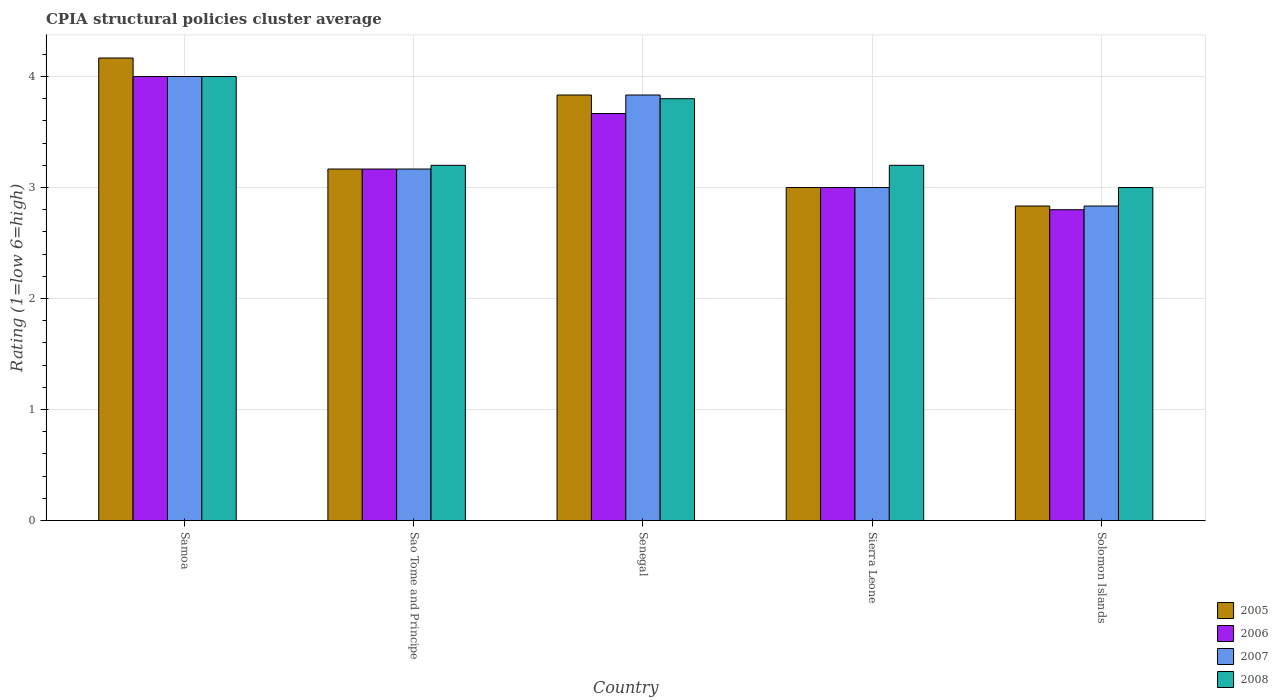Are the number of bars per tick equal to the number of legend labels?
Your answer should be compact. Yes. How many bars are there on the 1st tick from the left?
Your response must be concise. 4. What is the label of the 1st group of bars from the left?
Your response must be concise. Samoa. In how many cases, is the number of bars for a given country not equal to the number of legend labels?
Make the answer very short. 0. What is the CPIA rating in 2005 in Samoa?
Your response must be concise. 4.17. In which country was the CPIA rating in 2008 maximum?
Provide a succinct answer. Samoa. In which country was the CPIA rating in 2006 minimum?
Provide a succinct answer. Solomon Islands. What is the difference between the CPIA rating in 2006 in Senegal and that in Sierra Leone?
Ensure brevity in your answer.  0.67. What is the difference between the CPIA rating in 2006 in Sierra Leone and the CPIA rating in 2008 in Sao Tome and Principe?
Provide a short and direct response. -0.2. What is the average CPIA rating in 2005 per country?
Ensure brevity in your answer.  3.4. What is the difference between the CPIA rating of/in 2006 and CPIA rating of/in 2005 in Solomon Islands?
Your response must be concise. -0.03. In how many countries, is the CPIA rating in 2005 greater than 2.8?
Offer a very short reply. 5. What is the ratio of the CPIA rating in 2007 in Samoa to that in Sierra Leone?
Offer a very short reply. 1.33. Is the CPIA rating in 2005 in Senegal less than that in Sierra Leone?
Your response must be concise. No. Is the difference between the CPIA rating in 2006 in Samoa and Sierra Leone greater than the difference between the CPIA rating in 2005 in Samoa and Sierra Leone?
Provide a short and direct response. No. What is the difference between the highest and the second highest CPIA rating in 2007?
Ensure brevity in your answer.  -0.67. What is the difference between the highest and the lowest CPIA rating in 2007?
Your response must be concise. 1.17. In how many countries, is the CPIA rating in 2006 greater than the average CPIA rating in 2006 taken over all countries?
Offer a very short reply. 2. Is the sum of the CPIA rating in 2007 in Senegal and Sierra Leone greater than the maximum CPIA rating in 2008 across all countries?
Make the answer very short. Yes. Is it the case that in every country, the sum of the CPIA rating in 2007 and CPIA rating in 2006 is greater than the sum of CPIA rating in 2008 and CPIA rating in 2005?
Ensure brevity in your answer.  No. Is it the case that in every country, the sum of the CPIA rating in 2007 and CPIA rating in 2008 is greater than the CPIA rating in 2005?
Make the answer very short. Yes. Are the values on the major ticks of Y-axis written in scientific E-notation?
Ensure brevity in your answer.  No. Does the graph contain any zero values?
Your response must be concise. No. Does the graph contain grids?
Make the answer very short. Yes. Where does the legend appear in the graph?
Ensure brevity in your answer.  Bottom right. How many legend labels are there?
Provide a succinct answer. 4. How are the legend labels stacked?
Make the answer very short. Vertical. What is the title of the graph?
Provide a short and direct response. CPIA structural policies cluster average. Does "1997" appear as one of the legend labels in the graph?
Your answer should be compact. No. What is the label or title of the X-axis?
Provide a succinct answer. Country. What is the Rating (1=low 6=high) of 2005 in Samoa?
Provide a succinct answer. 4.17. What is the Rating (1=low 6=high) in 2006 in Samoa?
Keep it short and to the point. 4. What is the Rating (1=low 6=high) of 2008 in Samoa?
Give a very brief answer. 4. What is the Rating (1=low 6=high) of 2005 in Sao Tome and Principe?
Offer a terse response. 3.17. What is the Rating (1=low 6=high) of 2006 in Sao Tome and Principe?
Keep it short and to the point. 3.17. What is the Rating (1=low 6=high) of 2007 in Sao Tome and Principe?
Ensure brevity in your answer.  3.17. What is the Rating (1=low 6=high) of 2005 in Senegal?
Provide a short and direct response. 3.83. What is the Rating (1=low 6=high) of 2006 in Senegal?
Give a very brief answer. 3.67. What is the Rating (1=low 6=high) of 2007 in Senegal?
Offer a terse response. 3.83. What is the Rating (1=low 6=high) of 2008 in Senegal?
Make the answer very short. 3.8. What is the Rating (1=low 6=high) of 2007 in Sierra Leone?
Ensure brevity in your answer.  3. What is the Rating (1=low 6=high) of 2008 in Sierra Leone?
Make the answer very short. 3.2. What is the Rating (1=low 6=high) in 2005 in Solomon Islands?
Your answer should be compact. 2.83. What is the Rating (1=low 6=high) of 2007 in Solomon Islands?
Your response must be concise. 2.83. Across all countries, what is the maximum Rating (1=low 6=high) of 2005?
Your response must be concise. 4.17. Across all countries, what is the maximum Rating (1=low 6=high) of 2007?
Ensure brevity in your answer.  4. Across all countries, what is the minimum Rating (1=low 6=high) in 2005?
Provide a short and direct response. 2.83. Across all countries, what is the minimum Rating (1=low 6=high) in 2006?
Make the answer very short. 2.8. Across all countries, what is the minimum Rating (1=low 6=high) in 2007?
Your answer should be very brief. 2.83. What is the total Rating (1=low 6=high) in 2006 in the graph?
Offer a very short reply. 16.63. What is the total Rating (1=low 6=high) in 2007 in the graph?
Offer a terse response. 16.83. What is the total Rating (1=low 6=high) of 2008 in the graph?
Provide a succinct answer. 17.2. What is the difference between the Rating (1=low 6=high) in 2005 in Samoa and that in Sao Tome and Principe?
Offer a terse response. 1. What is the difference between the Rating (1=low 6=high) in 2006 in Samoa and that in Senegal?
Provide a succinct answer. 0.33. What is the difference between the Rating (1=low 6=high) of 2008 in Samoa and that in Senegal?
Provide a short and direct response. 0.2. What is the difference between the Rating (1=low 6=high) of 2008 in Samoa and that in Sierra Leone?
Your answer should be very brief. 0.8. What is the difference between the Rating (1=low 6=high) in 2005 in Samoa and that in Solomon Islands?
Provide a succinct answer. 1.33. What is the difference between the Rating (1=low 6=high) in 2005 in Sao Tome and Principe and that in Senegal?
Make the answer very short. -0.67. What is the difference between the Rating (1=low 6=high) of 2006 in Sao Tome and Principe and that in Senegal?
Offer a terse response. -0.5. What is the difference between the Rating (1=low 6=high) of 2008 in Sao Tome and Principe and that in Senegal?
Your answer should be very brief. -0.6. What is the difference between the Rating (1=low 6=high) of 2006 in Sao Tome and Principe and that in Sierra Leone?
Offer a terse response. 0.17. What is the difference between the Rating (1=low 6=high) in 2008 in Sao Tome and Principe and that in Sierra Leone?
Make the answer very short. 0. What is the difference between the Rating (1=low 6=high) in 2006 in Sao Tome and Principe and that in Solomon Islands?
Your answer should be very brief. 0.37. What is the difference between the Rating (1=low 6=high) in 2007 in Sao Tome and Principe and that in Solomon Islands?
Give a very brief answer. 0.33. What is the difference between the Rating (1=low 6=high) of 2008 in Sao Tome and Principe and that in Solomon Islands?
Your response must be concise. 0.2. What is the difference between the Rating (1=low 6=high) of 2006 in Senegal and that in Sierra Leone?
Provide a succinct answer. 0.67. What is the difference between the Rating (1=low 6=high) in 2005 in Senegal and that in Solomon Islands?
Keep it short and to the point. 1. What is the difference between the Rating (1=low 6=high) in 2006 in Senegal and that in Solomon Islands?
Your answer should be very brief. 0.87. What is the difference between the Rating (1=low 6=high) of 2007 in Senegal and that in Solomon Islands?
Your response must be concise. 1. What is the difference between the Rating (1=low 6=high) in 2006 in Sierra Leone and that in Solomon Islands?
Provide a short and direct response. 0.2. What is the difference between the Rating (1=low 6=high) of 2005 in Samoa and the Rating (1=low 6=high) of 2007 in Sao Tome and Principe?
Give a very brief answer. 1. What is the difference between the Rating (1=low 6=high) of 2005 in Samoa and the Rating (1=low 6=high) of 2008 in Sao Tome and Principe?
Your response must be concise. 0.97. What is the difference between the Rating (1=low 6=high) in 2006 in Samoa and the Rating (1=low 6=high) in 2007 in Sao Tome and Principe?
Offer a very short reply. 0.83. What is the difference between the Rating (1=low 6=high) in 2006 in Samoa and the Rating (1=low 6=high) in 2008 in Sao Tome and Principe?
Provide a succinct answer. 0.8. What is the difference between the Rating (1=low 6=high) in 2005 in Samoa and the Rating (1=low 6=high) in 2007 in Senegal?
Keep it short and to the point. 0.33. What is the difference between the Rating (1=low 6=high) of 2005 in Samoa and the Rating (1=low 6=high) of 2008 in Senegal?
Your response must be concise. 0.37. What is the difference between the Rating (1=low 6=high) of 2006 in Samoa and the Rating (1=low 6=high) of 2007 in Senegal?
Offer a terse response. 0.17. What is the difference between the Rating (1=low 6=high) of 2006 in Samoa and the Rating (1=low 6=high) of 2008 in Senegal?
Ensure brevity in your answer.  0.2. What is the difference between the Rating (1=low 6=high) of 2005 in Samoa and the Rating (1=low 6=high) of 2007 in Sierra Leone?
Offer a terse response. 1.17. What is the difference between the Rating (1=low 6=high) in 2005 in Samoa and the Rating (1=low 6=high) in 2008 in Sierra Leone?
Your response must be concise. 0.97. What is the difference between the Rating (1=low 6=high) of 2006 in Samoa and the Rating (1=low 6=high) of 2007 in Sierra Leone?
Ensure brevity in your answer.  1. What is the difference between the Rating (1=low 6=high) in 2007 in Samoa and the Rating (1=low 6=high) in 2008 in Sierra Leone?
Give a very brief answer. 0.8. What is the difference between the Rating (1=low 6=high) of 2005 in Samoa and the Rating (1=low 6=high) of 2006 in Solomon Islands?
Your response must be concise. 1.37. What is the difference between the Rating (1=low 6=high) of 2006 in Samoa and the Rating (1=low 6=high) of 2008 in Solomon Islands?
Provide a short and direct response. 1. What is the difference between the Rating (1=low 6=high) of 2007 in Samoa and the Rating (1=low 6=high) of 2008 in Solomon Islands?
Keep it short and to the point. 1. What is the difference between the Rating (1=low 6=high) in 2005 in Sao Tome and Principe and the Rating (1=low 6=high) in 2006 in Senegal?
Your answer should be very brief. -0.5. What is the difference between the Rating (1=low 6=high) of 2005 in Sao Tome and Principe and the Rating (1=low 6=high) of 2007 in Senegal?
Provide a short and direct response. -0.67. What is the difference between the Rating (1=low 6=high) of 2005 in Sao Tome and Principe and the Rating (1=low 6=high) of 2008 in Senegal?
Offer a terse response. -0.63. What is the difference between the Rating (1=low 6=high) of 2006 in Sao Tome and Principe and the Rating (1=low 6=high) of 2007 in Senegal?
Your answer should be very brief. -0.67. What is the difference between the Rating (1=low 6=high) of 2006 in Sao Tome and Principe and the Rating (1=low 6=high) of 2008 in Senegal?
Make the answer very short. -0.63. What is the difference between the Rating (1=low 6=high) in 2007 in Sao Tome and Principe and the Rating (1=low 6=high) in 2008 in Senegal?
Make the answer very short. -0.63. What is the difference between the Rating (1=low 6=high) in 2005 in Sao Tome and Principe and the Rating (1=low 6=high) in 2008 in Sierra Leone?
Keep it short and to the point. -0.03. What is the difference between the Rating (1=low 6=high) of 2006 in Sao Tome and Principe and the Rating (1=low 6=high) of 2008 in Sierra Leone?
Make the answer very short. -0.03. What is the difference between the Rating (1=low 6=high) in 2007 in Sao Tome and Principe and the Rating (1=low 6=high) in 2008 in Sierra Leone?
Provide a short and direct response. -0.03. What is the difference between the Rating (1=low 6=high) in 2005 in Sao Tome and Principe and the Rating (1=low 6=high) in 2006 in Solomon Islands?
Your answer should be very brief. 0.37. What is the difference between the Rating (1=low 6=high) of 2006 in Sao Tome and Principe and the Rating (1=low 6=high) of 2008 in Solomon Islands?
Provide a short and direct response. 0.17. What is the difference between the Rating (1=low 6=high) of 2005 in Senegal and the Rating (1=low 6=high) of 2007 in Sierra Leone?
Make the answer very short. 0.83. What is the difference between the Rating (1=low 6=high) of 2005 in Senegal and the Rating (1=low 6=high) of 2008 in Sierra Leone?
Make the answer very short. 0.63. What is the difference between the Rating (1=low 6=high) of 2006 in Senegal and the Rating (1=low 6=high) of 2007 in Sierra Leone?
Offer a very short reply. 0.67. What is the difference between the Rating (1=low 6=high) in 2006 in Senegal and the Rating (1=low 6=high) in 2008 in Sierra Leone?
Offer a very short reply. 0.47. What is the difference between the Rating (1=low 6=high) of 2007 in Senegal and the Rating (1=low 6=high) of 2008 in Sierra Leone?
Your answer should be compact. 0.63. What is the difference between the Rating (1=low 6=high) of 2005 in Senegal and the Rating (1=low 6=high) of 2007 in Solomon Islands?
Provide a short and direct response. 1. What is the difference between the Rating (1=low 6=high) in 2006 in Senegal and the Rating (1=low 6=high) in 2007 in Solomon Islands?
Keep it short and to the point. 0.83. What is the difference between the Rating (1=low 6=high) of 2007 in Senegal and the Rating (1=low 6=high) of 2008 in Solomon Islands?
Your response must be concise. 0.83. What is the difference between the Rating (1=low 6=high) of 2006 in Sierra Leone and the Rating (1=low 6=high) of 2007 in Solomon Islands?
Ensure brevity in your answer.  0.17. What is the difference between the Rating (1=low 6=high) of 2006 in Sierra Leone and the Rating (1=low 6=high) of 2008 in Solomon Islands?
Give a very brief answer. 0. What is the difference between the Rating (1=low 6=high) of 2007 in Sierra Leone and the Rating (1=low 6=high) of 2008 in Solomon Islands?
Your response must be concise. 0. What is the average Rating (1=low 6=high) in 2006 per country?
Keep it short and to the point. 3.33. What is the average Rating (1=low 6=high) of 2007 per country?
Ensure brevity in your answer.  3.37. What is the average Rating (1=low 6=high) in 2008 per country?
Provide a short and direct response. 3.44. What is the difference between the Rating (1=low 6=high) of 2005 and Rating (1=low 6=high) of 2008 in Samoa?
Offer a terse response. 0.17. What is the difference between the Rating (1=low 6=high) of 2006 and Rating (1=low 6=high) of 2008 in Samoa?
Your answer should be very brief. 0. What is the difference between the Rating (1=low 6=high) of 2007 and Rating (1=low 6=high) of 2008 in Samoa?
Ensure brevity in your answer.  0. What is the difference between the Rating (1=low 6=high) in 2005 and Rating (1=low 6=high) in 2006 in Sao Tome and Principe?
Your answer should be very brief. 0. What is the difference between the Rating (1=low 6=high) of 2005 and Rating (1=low 6=high) of 2008 in Sao Tome and Principe?
Your answer should be very brief. -0.03. What is the difference between the Rating (1=low 6=high) in 2006 and Rating (1=low 6=high) in 2008 in Sao Tome and Principe?
Your answer should be very brief. -0.03. What is the difference between the Rating (1=low 6=high) of 2007 and Rating (1=low 6=high) of 2008 in Sao Tome and Principe?
Make the answer very short. -0.03. What is the difference between the Rating (1=low 6=high) in 2005 and Rating (1=low 6=high) in 2006 in Senegal?
Provide a short and direct response. 0.17. What is the difference between the Rating (1=low 6=high) of 2005 and Rating (1=low 6=high) of 2007 in Senegal?
Offer a terse response. 0. What is the difference between the Rating (1=low 6=high) in 2006 and Rating (1=low 6=high) in 2008 in Senegal?
Your answer should be compact. -0.13. What is the difference between the Rating (1=low 6=high) in 2007 and Rating (1=low 6=high) in 2008 in Senegal?
Your response must be concise. 0.03. What is the difference between the Rating (1=low 6=high) in 2005 and Rating (1=low 6=high) in 2006 in Sierra Leone?
Your response must be concise. 0. What is the difference between the Rating (1=low 6=high) in 2005 and Rating (1=low 6=high) in 2007 in Sierra Leone?
Your response must be concise. 0. What is the difference between the Rating (1=low 6=high) in 2006 and Rating (1=low 6=high) in 2008 in Sierra Leone?
Provide a short and direct response. -0.2. What is the difference between the Rating (1=low 6=high) in 2006 and Rating (1=low 6=high) in 2007 in Solomon Islands?
Keep it short and to the point. -0.03. What is the difference between the Rating (1=low 6=high) in 2007 and Rating (1=low 6=high) in 2008 in Solomon Islands?
Keep it short and to the point. -0.17. What is the ratio of the Rating (1=low 6=high) of 2005 in Samoa to that in Sao Tome and Principe?
Make the answer very short. 1.32. What is the ratio of the Rating (1=low 6=high) in 2006 in Samoa to that in Sao Tome and Principe?
Your answer should be very brief. 1.26. What is the ratio of the Rating (1=low 6=high) in 2007 in Samoa to that in Sao Tome and Principe?
Your answer should be compact. 1.26. What is the ratio of the Rating (1=low 6=high) in 2008 in Samoa to that in Sao Tome and Principe?
Offer a terse response. 1.25. What is the ratio of the Rating (1=low 6=high) in 2005 in Samoa to that in Senegal?
Your response must be concise. 1.09. What is the ratio of the Rating (1=low 6=high) of 2007 in Samoa to that in Senegal?
Give a very brief answer. 1.04. What is the ratio of the Rating (1=low 6=high) in 2008 in Samoa to that in Senegal?
Your answer should be compact. 1.05. What is the ratio of the Rating (1=low 6=high) of 2005 in Samoa to that in Sierra Leone?
Your response must be concise. 1.39. What is the ratio of the Rating (1=low 6=high) of 2007 in Samoa to that in Sierra Leone?
Your answer should be compact. 1.33. What is the ratio of the Rating (1=low 6=high) in 2005 in Samoa to that in Solomon Islands?
Offer a very short reply. 1.47. What is the ratio of the Rating (1=low 6=high) of 2006 in Samoa to that in Solomon Islands?
Offer a very short reply. 1.43. What is the ratio of the Rating (1=low 6=high) of 2007 in Samoa to that in Solomon Islands?
Offer a terse response. 1.41. What is the ratio of the Rating (1=low 6=high) in 2005 in Sao Tome and Principe to that in Senegal?
Provide a short and direct response. 0.83. What is the ratio of the Rating (1=low 6=high) in 2006 in Sao Tome and Principe to that in Senegal?
Your answer should be compact. 0.86. What is the ratio of the Rating (1=low 6=high) of 2007 in Sao Tome and Principe to that in Senegal?
Offer a terse response. 0.83. What is the ratio of the Rating (1=low 6=high) of 2008 in Sao Tome and Principe to that in Senegal?
Provide a succinct answer. 0.84. What is the ratio of the Rating (1=low 6=high) of 2005 in Sao Tome and Principe to that in Sierra Leone?
Your answer should be compact. 1.06. What is the ratio of the Rating (1=low 6=high) of 2006 in Sao Tome and Principe to that in Sierra Leone?
Provide a succinct answer. 1.06. What is the ratio of the Rating (1=low 6=high) of 2007 in Sao Tome and Principe to that in Sierra Leone?
Provide a short and direct response. 1.06. What is the ratio of the Rating (1=low 6=high) of 2005 in Sao Tome and Principe to that in Solomon Islands?
Give a very brief answer. 1.12. What is the ratio of the Rating (1=low 6=high) of 2006 in Sao Tome and Principe to that in Solomon Islands?
Provide a succinct answer. 1.13. What is the ratio of the Rating (1=low 6=high) of 2007 in Sao Tome and Principe to that in Solomon Islands?
Keep it short and to the point. 1.12. What is the ratio of the Rating (1=low 6=high) of 2008 in Sao Tome and Principe to that in Solomon Islands?
Your response must be concise. 1.07. What is the ratio of the Rating (1=low 6=high) of 2005 in Senegal to that in Sierra Leone?
Your answer should be compact. 1.28. What is the ratio of the Rating (1=low 6=high) of 2006 in Senegal to that in Sierra Leone?
Your response must be concise. 1.22. What is the ratio of the Rating (1=low 6=high) in 2007 in Senegal to that in Sierra Leone?
Provide a succinct answer. 1.28. What is the ratio of the Rating (1=low 6=high) in 2008 in Senegal to that in Sierra Leone?
Your answer should be compact. 1.19. What is the ratio of the Rating (1=low 6=high) of 2005 in Senegal to that in Solomon Islands?
Your response must be concise. 1.35. What is the ratio of the Rating (1=low 6=high) in 2006 in Senegal to that in Solomon Islands?
Offer a terse response. 1.31. What is the ratio of the Rating (1=low 6=high) of 2007 in Senegal to that in Solomon Islands?
Your response must be concise. 1.35. What is the ratio of the Rating (1=low 6=high) in 2008 in Senegal to that in Solomon Islands?
Offer a very short reply. 1.27. What is the ratio of the Rating (1=low 6=high) in 2005 in Sierra Leone to that in Solomon Islands?
Your answer should be very brief. 1.06. What is the ratio of the Rating (1=low 6=high) of 2006 in Sierra Leone to that in Solomon Islands?
Make the answer very short. 1.07. What is the ratio of the Rating (1=low 6=high) in 2007 in Sierra Leone to that in Solomon Islands?
Offer a very short reply. 1.06. What is the ratio of the Rating (1=low 6=high) in 2008 in Sierra Leone to that in Solomon Islands?
Your answer should be compact. 1.07. What is the difference between the highest and the second highest Rating (1=low 6=high) in 2005?
Provide a succinct answer. 0.33. What is the difference between the highest and the lowest Rating (1=low 6=high) of 2005?
Your answer should be very brief. 1.33. What is the difference between the highest and the lowest Rating (1=low 6=high) in 2006?
Ensure brevity in your answer.  1.2. What is the difference between the highest and the lowest Rating (1=low 6=high) in 2007?
Provide a succinct answer. 1.17. What is the difference between the highest and the lowest Rating (1=low 6=high) in 2008?
Keep it short and to the point. 1. 